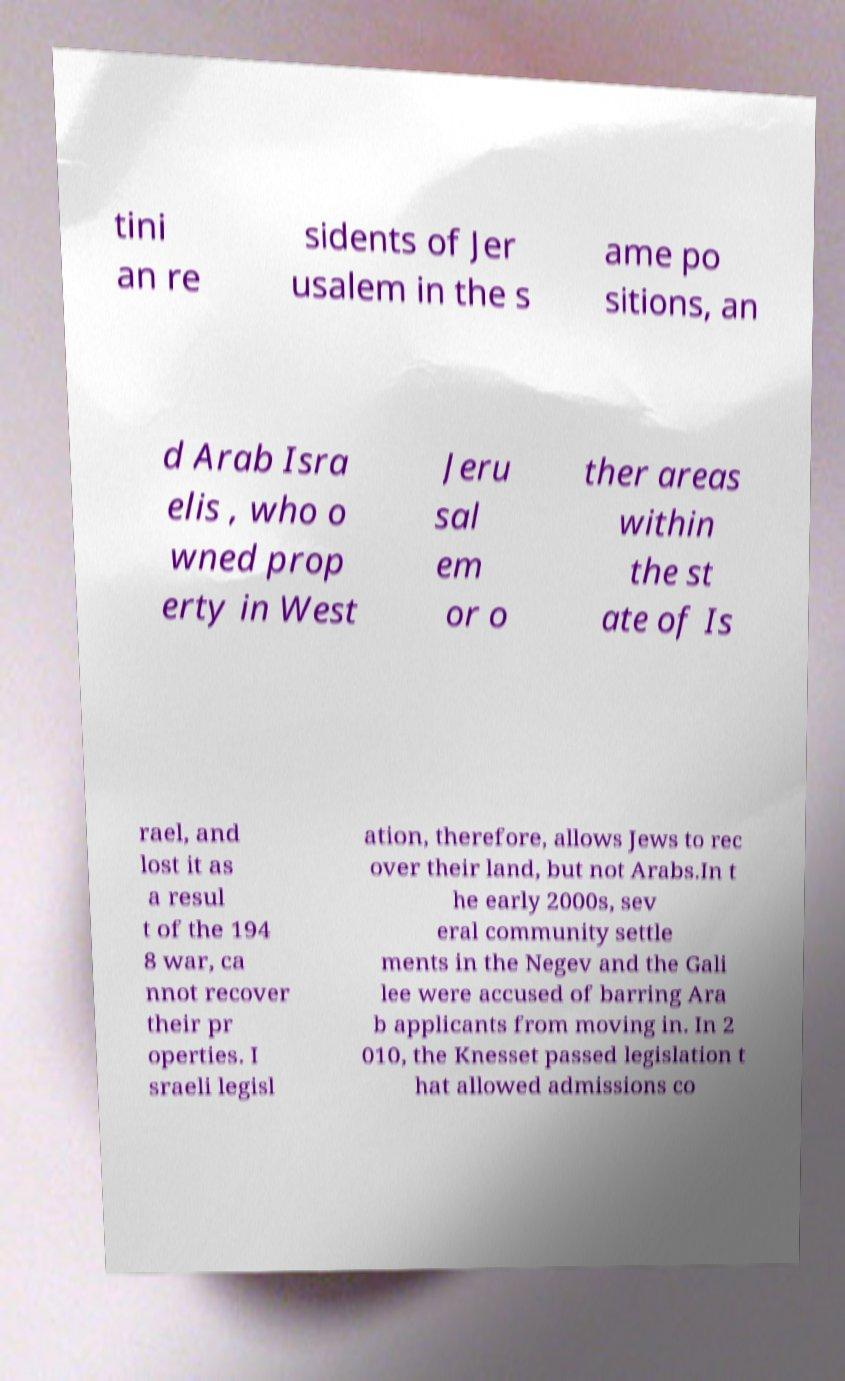Could you extract and type out the text from this image? tini an re sidents of Jer usalem in the s ame po sitions, an d Arab Isra elis , who o wned prop erty in West Jeru sal em or o ther areas within the st ate of Is rael, and lost it as a resul t of the 194 8 war, ca nnot recover their pr operties. I sraeli legisl ation, therefore, allows Jews to rec over their land, but not Arabs.In t he early 2000s, sev eral community settle ments in the Negev and the Gali lee were accused of barring Ara b applicants from moving in. In 2 010, the Knesset passed legislation t hat allowed admissions co 